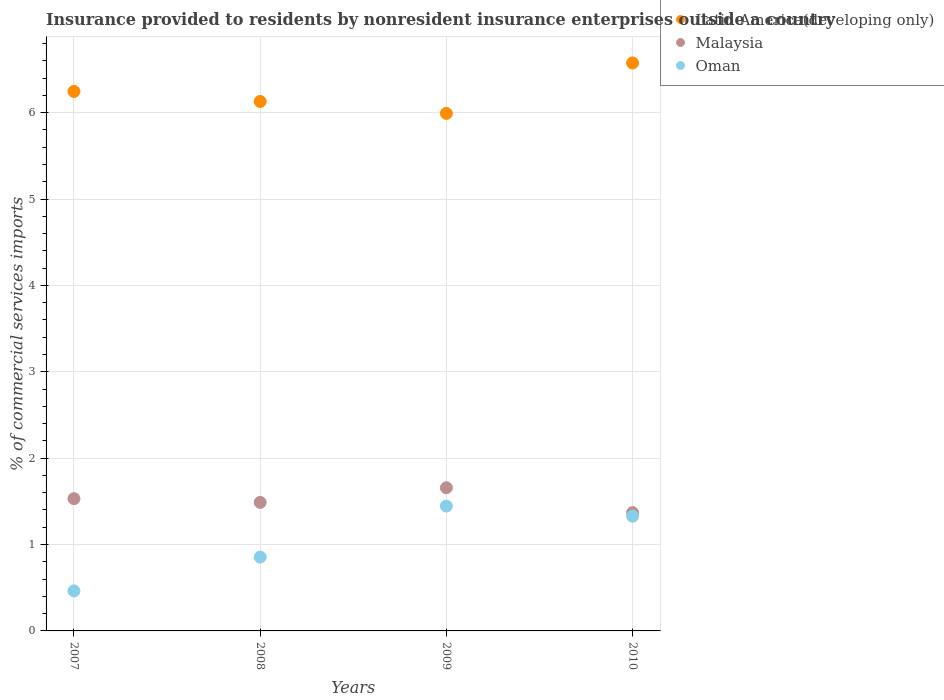How many different coloured dotlines are there?
Your answer should be very brief. 3. Is the number of dotlines equal to the number of legend labels?
Offer a very short reply. Yes. What is the Insurance provided to residents in Oman in 2010?
Your answer should be compact. 1.33. Across all years, what is the maximum Insurance provided to residents in Latin America(developing only)?
Your response must be concise. 6.57. Across all years, what is the minimum Insurance provided to residents in Malaysia?
Give a very brief answer. 1.37. What is the total Insurance provided to residents in Malaysia in the graph?
Make the answer very short. 6.05. What is the difference between the Insurance provided to residents in Oman in 2007 and that in 2008?
Your answer should be compact. -0.39. What is the difference between the Insurance provided to residents in Malaysia in 2008 and the Insurance provided to residents in Oman in 2007?
Offer a very short reply. 1.02. What is the average Insurance provided to residents in Latin America(developing only) per year?
Provide a short and direct response. 6.24. In the year 2009, what is the difference between the Insurance provided to residents in Latin America(developing only) and Insurance provided to residents in Oman?
Your response must be concise. 4.55. What is the ratio of the Insurance provided to residents in Malaysia in 2007 to that in 2010?
Give a very brief answer. 1.12. Is the Insurance provided to residents in Oman in 2007 less than that in 2010?
Provide a short and direct response. Yes. What is the difference between the highest and the second highest Insurance provided to residents in Oman?
Provide a succinct answer. 0.12. What is the difference between the highest and the lowest Insurance provided to residents in Malaysia?
Your answer should be compact. 0.29. Is the sum of the Insurance provided to residents in Malaysia in 2007 and 2010 greater than the maximum Insurance provided to residents in Oman across all years?
Provide a short and direct response. Yes. Is the Insurance provided to residents in Oman strictly greater than the Insurance provided to residents in Malaysia over the years?
Ensure brevity in your answer.  No. Is the Insurance provided to residents in Latin America(developing only) strictly less than the Insurance provided to residents in Oman over the years?
Ensure brevity in your answer.  No. Are the values on the major ticks of Y-axis written in scientific E-notation?
Offer a terse response. No. Does the graph contain any zero values?
Your answer should be compact. No. Does the graph contain grids?
Provide a succinct answer. Yes. How are the legend labels stacked?
Your answer should be very brief. Vertical. What is the title of the graph?
Make the answer very short. Insurance provided to residents by nonresident insurance enterprises outside a country. What is the label or title of the X-axis?
Offer a very short reply. Years. What is the label or title of the Y-axis?
Your response must be concise. % of commercial services imports. What is the % of commercial services imports in Latin America(developing only) in 2007?
Provide a succinct answer. 6.25. What is the % of commercial services imports of Malaysia in 2007?
Offer a terse response. 1.53. What is the % of commercial services imports of Oman in 2007?
Your answer should be very brief. 0.46. What is the % of commercial services imports in Latin America(developing only) in 2008?
Your answer should be very brief. 6.13. What is the % of commercial services imports in Malaysia in 2008?
Ensure brevity in your answer.  1.49. What is the % of commercial services imports in Oman in 2008?
Give a very brief answer. 0.85. What is the % of commercial services imports in Latin America(developing only) in 2009?
Your response must be concise. 5.99. What is the % of commercial services imports of Malaysia in 2009?
Provide a succinct answer. 1.66. What is the % of commercial services imports in Oman in 2009?
Your answer should be very brief. 1.44. What is the % of commercial services imports in Latin America(developing only) in 2010?
Provide a succinct answer. 6.57. What is the % of commercial services imports of Malaysia in 2010?
Your answer should be very brief. 1.37. What is the % of commercial services imports in Oman in 2010?
Provide a succinct answer. 1.33. Across all years, what is the maximum % of commercial services imports of Latin America(developing only)?
Keep it short and to the point. 6.57. Across all years, what is the maximum % of commercial services imports of Malaysia?
Your answer should be compact. 1.66. Across all years, what is the maximum % of commercial services imports in Oman?
Your answer should be very brief. 1.44. Across all years, what is the minimum % of commercial services imports in Latin America(developing only)?
Provide a succinct answer. 5.99. Across all years, what is the minimum % of commercial services imports of Malaysia?
Your answer should be compact. 1.37. Across all years, what is the minimum % of commercial services imports in Oman?
Offer a terse response. 0.46. What is the total % of commercial services imports of Latin America(developing only) in the graph?
Offer a terse response. 24.94. What is the total % of commercial services imports in Malaysia in the graph?
Your answer should be very brief. 6.05. What is the total % of commercial services imports in Oman in the graph?
Your answer should be compact. 4.09. What is the difference between the % of commercial services imports of Latin America(developing only) in 2007 and that in 2008?
Your response must be concise. 0.12. What is the difference between the % of commercial services imports in Malaysia in 2007 and that in 2008?
Provide a short and direct response. 0.04. What is the difference between the % of commercial services imports in Oman in 2007 and that in 2008?
Ensure brevity in your answer.  -0.39. What is the difference between the % of commercial services imports of Latin America(developing only) in 2007 and that in 2009?
Provide a succinct answer. 0.25. What is the difference between the % of commercial services imports of Malaysia in 2007 and that in 2009?
Your answer should be very brief. -0.13. What is the difference between the % of commercial services imports in Oman in 2007 and that in 2009?
Keep it short and to the point. -0.98. What is the difference between the % of commercial services imports in Latin America(developing only) in 2007 and that in 2010?
Your answer should be compact. -0.33. What is the difference between the % of commercial services imports in Malaysia in 2007 and that in 2010?
Give a very brief answer. 0.16. What is the difference between the % of commercial services imports in Oman in 2007 and that in 2010?
Offer a terse response. -0.86. What is the difference between the % of commercial services imports in Latin America(developing only) in 2008 and that in 2009?
Offer a terse response. 0.14. What is the difference between the % of commercial services imports of Malaysia in 2008 and that in 2009?
Make the answer very short. -0.17. What is the difference between the % of commercial services imports of Oman in 2008 and that in 2009?
Keep it short and to the point. -0.59. What is the difference between the % of commercial services imports in Latin America(developing only) in 2008 and that in 2010?
Keep it short and to the point. -0.45. What is the difference between the % of commercial services imports of Malaysia in 2008 and that in 2010?
Offer a very short reply. 0.12. What is the difference between the % of commercial services imports of Oman in 2008 and that in 2010?
Your answer should be very brief. -0.47. What is the difference between the % of commercial services imports in Latin America(developing only) in 2009 and that in 2010?
Provide a succinct answer. -0.58. What is the difference between the % of commercial services imports of Malaysia in 2009 and that in 2010?
Your response must be concise. 0.29. What is the difference between the % of commercial services imports in Oman in 2009 and that in 2010?
Provide a succinct answer. 0.12. What is the difference between the % of commercial services imports in Latin America(developing only) in 2007 and the % of commercial services imports in Malaysia in 2008?
Your response must be concise. 4.76. What is the difference between the % of commercial services imports of Latin America(developing only) in 2007 and the % of commercial services imports of Oman in 2008?
Give a very brief answer. 5.39. What is the difference between the % of commercial services imports of Malaysia in 2007 and the % of commercial services imports of Oman in 2008?
Provide a succinct answer. 0.68. What is the difference between the % of commercial services imports of Latin America(developing only) in 2007 and the % of commercial services imports of Malaysia in 2009?
Provide a short and direct response. 4.59. What is the difference between the % of commercial services imports in Latin America(developing only) in 2007 and the % of commercial services imports in Oman in 2009?
Give a very brief answer. 4.8. What is the difference between the % of commercial services imports of Malaysia in 2007 and the % of commercial services imports of Oman in 2009?
Make the answer very short. 0.09. What is the difference between the % of commercial services imports of Latin America(developing only) in 2007 and the % of commercial services imports of Malaysia in 2010?
Provide a succinct answer. 4.88. What is the difference between the % of commercial services imports of Latin America(developing only) in 2007 and the % of commercial services imports of Oman in 2010?
Provide a short and direct response. 4.92. What is the difference between the % of commercial services imports in Malaysia in 2007 and the % of commercial services imports in Oman in 2010?
Make the answer very short. 0.2. What is the difference between the % of commercial services imports in Latin America(developing only) in 2008 and the % of commercial services imports in Malaysia in 2009?
Keep it short and to the point. 4.47. What is the difference between the % of commercial services imports in Latin America(developing only) in 2008 and the % of commercial services imports in Oman in 2009?
Keep it short and to the point. 4.68. What is the difference between the % of commercial services imports of Malaysia in 2008 and the % of commercial services imports of Oman in 2009?
Provide a short and direct response. 0.04. What is the difference between the % of commercial services imports in Latin America(developing only) in 2008 and the % of commercial services imports in Malaysia in 2010?
Offer a terse response. 4.76. What is the difference between the % of commercial services imports in Latin America(developing only) in 2008 and the % of commercial services imports in Oman in 2010?
Provide a short and direct response. 4.8. What is the difference between the % of commercial services imports of Malaysia in 2008 and the % of commercial services imports of Oman in 2010?
Ensure brevity in your answer.  0.16. What is the difference between the % of commercial services imports in Latin America(developing only) in 2009 and the % of commercial services imports in Malaysia in 2010?
Give a very brief answer. 4.62. What is the difference between the % of commercial services imports in Latin America(developing only) in 2009 and the % of commercial services imports in Oman in 2010?
Make the answer very short. 4.66. What is the difference between the % of commercial services imports of Malaysia in 2009 and the % of commercial services imports of Oman in 2010?
Provide a succinct answer. 0.33. What is the average % of commercial services imports in Latin America(developing only) per year?
Make the answer very short. 6.24. What is the average % of commercial services imports in Malaysia per year?
Make the answer very short. 1.51. What is the average % of commercial services imports in Oman per year?
Keep it short and to the point. 1.02. In the year 2007, what is the difference between the % of commercial services imports in Latin America(developing only) and % of commercial services imports in Malaysia?
Keep it short and to the point. 4.71. In the year 2007, what is the difference between the % of commercial services imports of Latin America(developing only) and % of commercial services imports of Oman?
Give a very brief answer. 5.78. In the year 2007, what is the difference between the % of commercial services imports in Malaysia and % of commercial services imports in Oman?
Your answer should be compact. 1.07. In the year 2008, what is the difference between the % of commercial services imports in Latin America(developing only) and % of commercial services imports in Malaysia?
Make the answer very short. 4.64. In the year 2008, what is the difference between the % of commercial services imports in Latin America(developing only) and % of commercial services imports in Oman?
Your answer should be very brief. 5.27. In the year 2008, what is the difference between the % of commercial services imports in Malaysia and % of commercial services imports in Oman?
Offer a very short reply. 0.63. In the year 2009, what is the difference between the % of commercial services imports in Latin America(developing only) and % of commercial services imports in Malaysia?
Your answer should be compact. 4.33. In the year 2009, what is the difference between the % of commercial services imports in Latin America(developing only) and % of commercial services imports in Oman?
Your answer should be compact. 4.55. In the year 2009, what is the difference between the % of commercial services imports in Malaysia and % of commercial services imports in Oman?
Provide a succinct answer. 0.21. In the year 2010, what is the difference between the % of commercial services imports in Latin America(developing only) and % of commercial services imports in Malaysia?
Offer a very short reply. 5.21. In the year 2010, what is the difference between the % of commercial services imports of Latin America(developing only) and % of commercial services imports of Oman?
Provide a succinct answer. 5.25. In the year 2010, what is the difference between the % of commercial services imports in Malaysia and % of commercial services imports in Oman?
Provide a short and direct response. 0.04. What is the ratio of the % of commercial services imports of Latin America(developing only) in 2007 to that in 2008?
Ensure brevity in your answer.  1.02. What is the ratio of the % of commercial services imports in Malaysia in 2007 to that in 2008?
Offer a very short reply. 1.03. What is the ratio of the % of commercial services imports in Oman in 2007 to that in 2008?
Make the answer very short. 0.54. What is the ratio of the % of commercial services imports in Latin America(developing only) in 2007 to that in 2009?
Keep it short and to the point. 1.04. What is the ratio of the % of commercial services imports of Malaysia in 2007 to that in 2009?
Provide a short and direct response. 0.92. What is the ratio of the % of commercial services imports in Oman in 2007 to that in 2009?
Make the answer very short. 0.32. What is the ratio of the % of commercial services imports of Latin America(developing only) in 2007 to that in 2010?
Your response must be concise. 0.95. What is the ratio of the % of commercial services imports in Malaysia in 2007 to that in 2010?
Provide a short and direct response. 1.12. What is the ratio of the % of commercial services imports in Oman in 2007 to that in 2010?
Your answer should be very brief. 0.35. What is the ratio of the % of commercial services imports of Latin America(developing only) in 2008 to that in 2009?
Provide a short and direct response. 1.02. What is the ratio of the % of commercial services imports of Malaysia in 2008 to that in 2009?
Provide a short and direct response. 0.9. What is the ratio of the % of commercial services imports of Oman in 2008 to that in 2009?
Ensure brevity in your answer.  0.59. What is the ratio of the % of commercial services imports of Latin America(developing only) in 2008 to that in 2010?
Offer a terse response. 0.93. What is the ratio of the % of commercial services imports in Malaysia in 2008 to that in 2010?
Your response must be concise. 1.09. What is the ratio of the % of commercial services imports of Oman in 2008 to that in 2010?
Provide a short and direct response. 0.64. What is the ratio of the % of commercial services imports in Latin America(developing only) in 2009 to that in 2010?
Keep it short and to the point. 0.91. What is the ratio of the % of commercial services imports in Malaysia in 2009 to that in 2010?
Your response must be concise. 1.21. What is the ratio of the % of commercial services imports of Oman in 2009 to that in 2010?
Your answer should be very brief. 1.09. What is the difference between the highest and the second highest % of commercial services imports of Latin America(developing only)?
Provide a succinct answer. 0.33. What is the difference between the highest and the second highest % of commercial services imports of Malaysia?
Your answer should be compact. 0.13. What is the difference between the highest and the second highest % of commercial services imports of Oman?
Your answer should be compact. 0.12. What is the difference between the highest and the lowest % of commercial services imports of Latin America(developing only)?
Your answer should be compact. 0.58. What is the difference between the highest and the lowest % of commercial services imports in Malaysia?
Offer a terse response. 0.29. What is the difference between the highest and the lowest % of commercial services imports of Oman?
Provide a short and direct response. 0.98. 